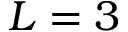Convert formula to latex. <formula><loc_0><loc_0><loc_500><loc_500>L = 3</formula> 